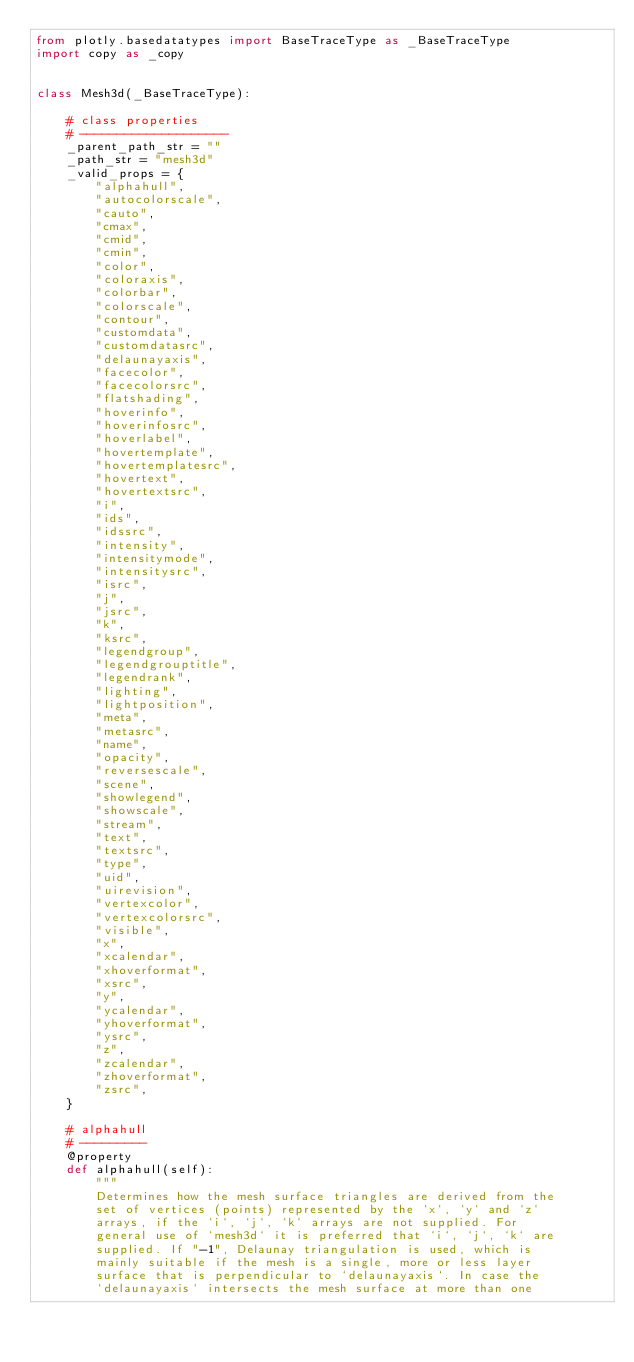Convert code to text. <code><loc_0><loc_0><loc_500><loc_500><_Python_>from plotly.basedatatypes import BaseTraceType as _BaseTraceType
import copy as _copy


class Mesh3d(_BaseTraceType):

    # class properties
    # --------------------
    _parent_path_str = ""
    _path_str = "mesh3d"
    _valid_props = {
        "alphahull",
        "autocolorscale",
        "cauto",
        "cmax",
        "cmid",
        "cmin",
        "color",
        "coloraxis",
        "colorbar",
        "colorscale",
        "contour",
        "customdata",
        "customdatasrc",
        "delaunayaxis",
        "facecolor",
        "facecolorsrc",
        "flatshading",
        "hoverinfo",
        "hoverinfosrc",
        "hoverlabel",
        "hovertemplate",
        "hovertemplatesrc",
        "hovertext",
        "hovertextsrc",
        "i",
        "ids",
        "idssrc",
        "intensity",
        "intensitymode",
        "intensitysrc",
        "isrc",
        "j",
        "jsrc",
        "k",
        "ksrc",
        "legendgroup",
        "legendgrouptitle",
        "legendrank",
        "lighting",
        "lightposition",
        "meta",
        "metasrc",
        "name",
        "opacity",
        "reversescale",
        "scene",
        "showlegend",
        "showscale",
        "stream",
        "text",
        "textsrc",
        "type",
        "uid",
        "uirevision",
        "vertexcolor",
        "vertexcolorsrc",
        "visible",
        "x",
        "xcalendar",
        "xhoverformat",
        "xsrc",
        "y",
        "ycalendar",
        "yhoverformat",
        "ysrc",
        "z",
        "zcalendar",
        "zhoverformat",
        "zsrc",
    }

    # alphahull
    # ---------
    @property
    def alphahull(self):
        """
        Determines how the mesh surface triangles are derived from the
        set of vertices (points) represented by the `x`, `y` and `z`
        arrays, if the `i`, `j`, `k` arrays are not supplied. For
        general use of `mesh3d` it is preferred that `i`, `j`, `k` are
        supplied. If "-1", Delaunay triangulation is used, which is
        mainly suitable if the mesh is a single, more or less layer
        surface that is perpendicular to `delaunayaxis`. In case the
        `delaunayaxis` intersects the mesh surface at more than one</code> 